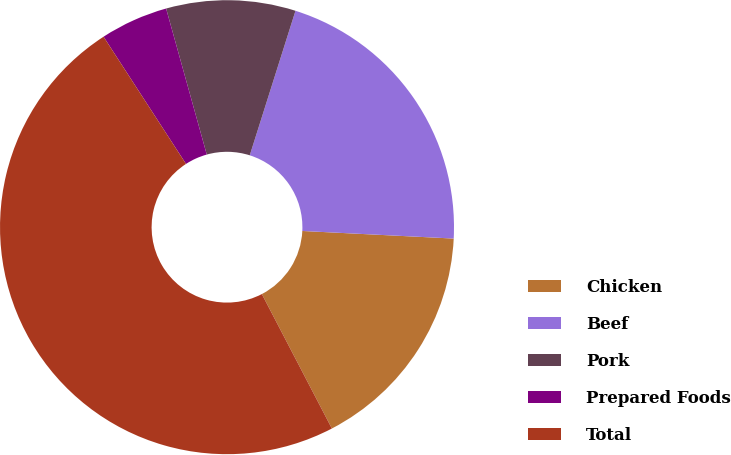Convert chart to OTSL. <chart><loc_0><loc_0><loc_500><loc_500><pie_chart><fcel>Chicken<fcel>Beef<fcel>Pork<fcel>Prepared Foods<fcel>Total<nl><fcel>16.56%<fcel>20.92%<fcel>9.2%<fcel>4.83%<fcel>48.49%<nl></chart> 